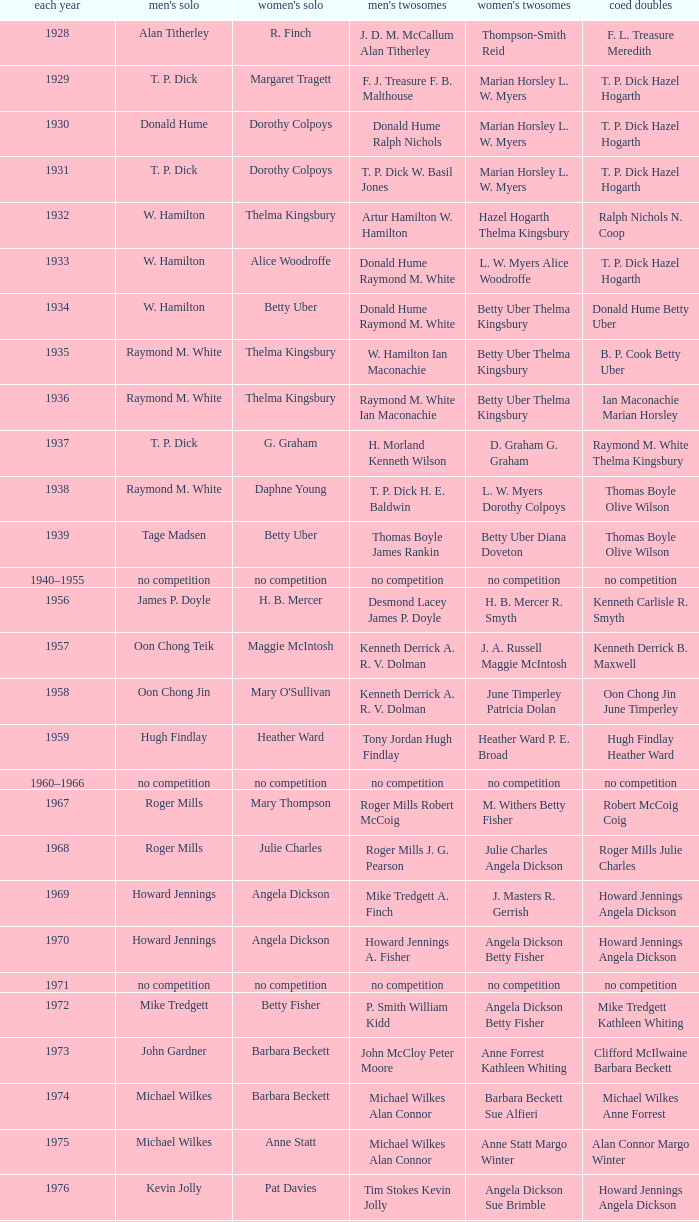Who won the Women's singles, in the year that Raymond M. White won the Men's singles and that W. Hamilton Ian Maconachie won the Men's doubles? Thelma Kingsbury. Could you help me parse every detail presented in this table? {'header': ['each year', "men's solo", "women's solo", "men's twosomes", "women's twosomes", 'coed doubles'], 'rows': [['1928', 'Alan Titherley', 'R. Finch', 'J. D. M. McCallum Alan Titherley', 'Thompson-Smith Reid', 'F. L. Treasure Meredith'], ['1929', 'T. P. Dick', 'Margaret Tragett', 'F. J. Treasure F. B. Malthouse', 'Marian Horsley L. W. Myers', 'T. P. Dick Hazel Hogarth'], ['1930', 'Donald Hume', 'Dorothy Colpoys', 'Donald Hume Ralph Nichols', 'Marian Horsley L. W. Myers', 'T. P. Dick Hazel Hogarth'], ['1931', 'T. P. Dick', 'Dorothy Colpoys', 'T. P. Dick W. Basil Jones', 'Marian Horsley L. W. Myers', 'T. P. Dick Hazel Hogarth'], ['1932', 'W. Hamilton', 'Thelma Kingsbury', 'Artur Hamilton W. Hamilton', 'Hazel Hogarth Thelma Kingsbury', 'Ralph Nichols N. Coop'], ['1933', 'W. Hamilton', 'Alice Woodroffe', 'Donald Hume Raymond M. White', 'L. W. Myers Alice Woodroffe', 'T. P. Dick Hazel Hogarth'], ['1934', 'W. Hamilton', 'Betty Uber', 'Donald Hume Raymond M. White', 'Betty Uber Thelma Kingsbury', 'Donald Hume Betty Uber'], ['1935', 'Raymond M. White', 'Thelma Kingsbury', 'W. Hamilton Ian Maconachie', 'Betty Uber Thelma Kingsbury', 'B. P. Cook Betty Uber'], ['1936', 'Raymond M. White', 'Thelma Kingsbury', 'Raymond M. White Ian Maconachie', 'Betty Uber Thelma Kingsbury', 'Ian Maconachie Marian Horsley'], ['1937', 'T. P. Dick', 'G. Graham', 'H. Morland Kenneth Wilson', 'D. Graham G. Graham', 'Raymond M. White Thelma Kingsbury'], ['1938', 'Raymond M. White', 'Daphne Young', 'T. P. Dick H. E. Baldwin', 'L. W. Myers Dorothy Colpoys', 'Thomas Boyle Olive Wilson'], ['1939', 'Tage Madsen', 'Betty Uber', 'Thomas Boyle James Rankin', 'Betty Uber Diana Doveton', 'Thomas Boyle Olive Wilson'], ['1940–1955', 'no competition', 'no competition', 'no competition', 'no competition', 'no competition'], ['1956', 'James P. Doyle', 'H. B. Mercer', 'Desmond Lacey James P. Doyle', 'H. B. Mercer R. Smyth', 'Kenneth Carlisle R. Smyth'], ['1957', 'Oon Chong Teik', 'Maggie McIntosh', 'Kenneth Derrick A. R. V. Dolman', 'J. A. Russell Maggie McIntosh', 'Kenneth Derrick B. Maxwell'], ['1958', 'Oon Chong Jin', "Mary O'Sullivan", 'Kenneth Derrick A. R. V. Dolman', 'June Timperley Patricia Dolan', 'Oon Chong Jin June Timperley'], ['1959', 'Hugh Findlay', 'Heather Ward', 'Tony Jordan Hugh Findlay', 'Heather Ward P. E. Broad', 'Hugh Findlay Heather Ward'], ['1960–1966', 'no competition', 'no competition', 'no competition', 'no competition', 'no competition'], ['1967', 'Roger Mills', 'Mary Thompson', 'Roger Mills Robert McCoig', 'M. Withers Betty Fisher', 'Robert McCoig Coig'], ['1968', 'Roger Mills', 'Julie Charles', 'Roger Mills J. G. Pearson', 'Julie Charles Angela Dickson', 'Roger Mills Julie Charles'], ['1969', 'Howard Jennings', 'Angela Dickson', 'Mike Tredgett A. Finch', 'J. Masters R. Gerrish', 'Howard Jennings Angela Dickson'], ['1970', 'Howard Jennings', 'Angela Dickson', 'Howard Jennings A. Fisher', 'Angela Dickson Betty Fisher', 'Howard Jennings Angela Dickson'], ['1971', 'no competition', 'no competition', 'no competition', 'no competition', 'no competition'], ['1972', 'Mike Tredgett', 'Betty Fisher', 'P. Smith William Kidd', 'Angela Dickson Betty Fisher', 'Mike Tredgett Kathleen Whiting'], ['1973', 'John Gardner', 'Barbara Beckett', 'John McCloy Peter Moore', 'Anne Forrest Kathleen Whiting', 'Clifford McIlwaine Barbara Beckett'], ['1974', 'Michael Wilkes', 'Barbara Beckett', 'Michael Wilkes Alan Connor', 'Barbara Beckett Sue Alfieri', 'Michael Wilkes Anne Forrest'], ['1975', 'Michael Wilkes', 'Anne Statt', 'Michael Wilkes Alan Connor', 'Anne Statt Margo Winter', 'Alan Connor Margo Winter'], ['1976', 'Kevin Jolly', 'Pat Davies', 'Tim Stokes Kevin Jolly', 'Angela Dickson Sue Brimble', 'Howard Jennings Angela Dickson'], ['1977', 'David Eddy', 'Paula Kilvington', 'David Eddy Eddy Sutton', 'Anne Statt Jane Webster', 'David Eddy Barbara Giles'], ['1978', 'Mike Tredgett', 'Gillian Gilks', 'David Eddy Eddy Sutton', 'Barbara Sutton Marjan Ridder', 'Elliot Stuart Gillian Gilks'], ['1979', 'Kevin Jolly', 'Nora Perry', 'Ray Stevens Mike Tredgett', 'Barbara Sutton Nora Perry', 'Mike Tredgett Nora Perry'], ['1980', 'Thomas Kihlström', 'Jane Webster', 'Thomas Kihlström Bengt Fröman', 'Jane Webster Karen Puttick', 'Billy Gilliland Karen Puttick'], ['1981', 'Ray Stevens', 'Gillian Gilks', 'Ray Stevens Mike Tredgett', 'Gillian Gilks Paula Kilvington', 'Mike Tredgett Nora Perry'], ['1982', 'Steve Baddeley', 'Karen Bridge', 'David Eddy Eddy Sutton', 'Karen Chapman Sally Podger', 'Billy Gilliland Karen Chapman'], ['1983', 'Steve Butler', 'Sally Podger', 'Mike Tredgett Dipak Tailor', 'Nora Perry Jane Webster', 'Dipak Tailor Nora Perry'], ['1984', 'Steve Butler', 'Karen Beckman', 'Mike Tredgett Martin Dew', 'Helen Troke Karen Chapman', 'Mike Tredgett Karen Chapman'], ['1985', 'Morten Frost', 'Charlotte Hattens', 'Billy Gilliland Dan Travers', 'Gillian Gilks Helen Troke', 'Martin Dew Gillian Gilks'], ['1986', 'Darren Hall', 'Fiona Elliott', 'Martin Dew Dipak Tailor', 'Karen Beckman Sara Halsall', 'Jesper Knudsen Nettie Nielsen'], ['1987', 'Darren Hall', 'Fiona Elliott', 'Martin Dew Darren Hall', 'Karen Beckman Sara Halsall', 'Martin Dew Gillian Gilks'], ['1988', 'Vimal Kumar', 'Lee Jung-mi', 'Richard Outterside Mike Brown', 'Fiona Elliott Sara Halsall', 'Martin Dew Gillian Gilks'], ['1989', 'Darren Hall', 'Bang Soo-hyun', 'Nick Ponting Dave Wright', 'Karen Beckman Sara Sankey', 'Mike Brown Jillian Wallwork'], ['1990', 'Mathew Smith', 'Joanne Muggeridge', 'Nick Ponting Dave Wright', 'Karen Chapman Sara Sankey', 'Dave Wright Claire Palmer'], ['1991', 'Vimal Kumar', 'Denyse Julien', 'Nick Ponting Dave Wright', 'Cheryl Johnson Julie Bradbury', 'Nick Ponting Joanne Wright'], ['1992', 'Wei Yan', 'Fiona Smith', 'Michael Adams Chris Rees', 'Denyse Julien Doris Piché', 'Andy Goode Joanne Wright'], ['1993', 'Anders Nielsen', 'Sue Louis Lane', 'Nick Ponting Dave Wright', 'Julie Bradbury Sara Sankey', 'Nick Ponting Joanne Wright'], ['1994', 'Darren Hall', 'Marina Andrievskaya', 'Michael Adams Simon Archer', 'Julie Bradbury Joanne Wright', 'Chris Hunt Joanne Wright'], ['1995', 'Peter Rasmussen', 'Denyse Julien', 'Andrei Andropov Nikolai Zuyev', 'Julie Bradbury Joanne Wright', 'Nick Ponting Joanne Wright'], ['1996', 'Colin Haughton', 'Elena Rybkina', 'Andrei Andropov Nikolai Zuyev', 'Elena Rybkina Marina Yakusheva', 'Nikolai Zuyev Marina Yakusheva'], ['1997', 'Chris Bruil', 'Kelly Morgan', 'Ian Pearson James Anderson', 'Nicole van Hooren Brenda Conijn', 'Quinten van Dalm Nicole van Hooren'], ['1998', 'Dicky Palyama', 'Brenda Beenhakker', 'James Anderson Ian Sullivan', 'Sara Sankey Ella Tripp', 'James Anderson Sara Sankey'], ['1999', 'Daniel Eriksson', 'Marina Andrievskaya', 'Joachim Tesche Jean-Philippe Goyette', 'Marina Andrievskaya Catrine Bengtsson', 'Henrik Andersson Marina Andrievskaya'], ['2000', 'Richard Vaughan', 'Marina Yakusheva', 'Joachim Andersson Peter Axelsson', 'Irina Ruslyakova Marina Yakusheva', 'Peter Jeffrey Joanne Davies'], ['2001', 'Irwansyah', 'Brenda Beenhakker', 'Vincent Laigle Svetoslav Stoyanov', 'Sara Sankey Ella Tripp', 'Nikolai Zuyev Marina Yakusheva'], ['2002', 'Irwansyah', 'Karina de Wit', 'Nikolai Zuyev Stanislav Pukhov', 'Ella Tripp Joanne Wright', 'Nikolai Zuyev Marina Yakusheva'], ['2003', 'Irwansyah', 'Ella Karachkova', 'Ashley Thilthorpe Kristian Roebuck', 'Ella Karachkova Anastasia Russkikh', 'Alexandr Russkikh Anastasia Russkikh'], ['2004', 'Nathan Rice', 'Petya Nedelcheva', 'Reuben Gordown Aji Basuki Sindoro', 'Petya Nedelcheva Yuan Wemyss', 'Matthew Hughes Kelly Morgan'], ['2005', 'Chetan Anand', 'Eleanor Cox', 'Andrew Ellis Dean George', 'Hayley Connor Heather Olver', 'Valiyaveetil Diju Jwala Gutta'], ['2006', 'Irwansyah', 'Huang Chia-chi', 'Matthew Hughes Martyn Lewis', 'Natalie Munt Mariana Agathangelou', 'Kristian Roebuck Natalie Munt'], ['2007', 'Marc Zwiebler', 'Jill Pittard', 'Wojciech Szkudlarczyk Adam Cwalina', 'Chloe Magee Bing Huang', 'Wojciech Szkudlarczyk Malgorzata Kurdelska'], ['2008', 'Brice Leverdez', 'Kati Tolmoff', 'Andrew Bowman Martyn Lewis', 'Mariana Agathangelou Jillie Cooper', 'Watson Briggs Jillie Cooper'], ['2009', 'Kristian Nielsen', 'Tatjana Bibik', 'Vitaliy Durkin Alexandr Nikolaenko', 'Valeria Sorokina Nina Vislova', 'Vitaliy Durkin Nina Vislova'], ['2010', 'Pablo Abián', 'Anita Raj Kaur', 'Peter Käsbauer Josche Zurwonne', 'Joanne Quay Swee Ling Anita Raj Kaur', 'Peter Käsbauer Johanna Goliszewski'], ['2011', 'Niluka Karunaratne', 'Nicole Schaller', 'Chris Coles Matthew Nottingham', 'Ng Hui Ern Ng Hui Lin', 'Martin Campbell Ng Hui Lin'], ['2012', 'Chou Tien-chen', 'Chiang Mei-hui', 'Marcus Ellis Paul Van Rietvelde', 'Gabrielle White Lauren Smith', 'Marcus Ellis Gabrielle White']]} 